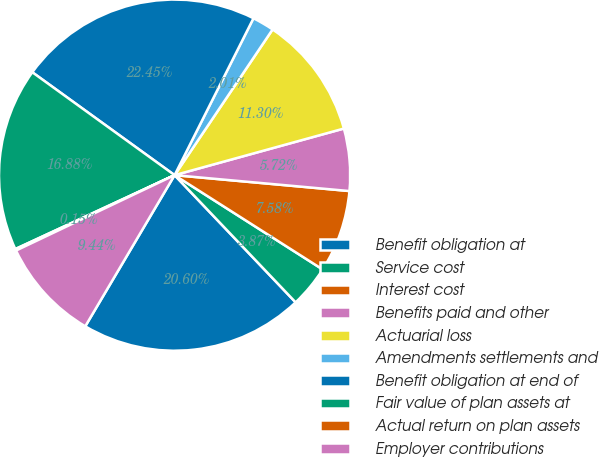Convert chart. <chart><loc_0><loc_0><loc_500><loc_500><pie_chart><fcel>Benefit obligation at<fcel>Service cost<fcel>Interest cost<fcel>Benefits paid and other<fcel>Actuarial loss<fcel>Amendments settlements and<fcel>Benefit obligation at end of<fcel>Fair value of plan assets at<fcel>Actual return on plan assets<fcel>Employer contributions<nl><fcel>20.6%<fcel>3.87%<fcel>7.58%<fcel>5.72%<fcel>11.3%<fcel>2.01%<fcel>22.45%<fcel>16.88%<fcel>0.15%<fcel>9.44%<nl></chart> 